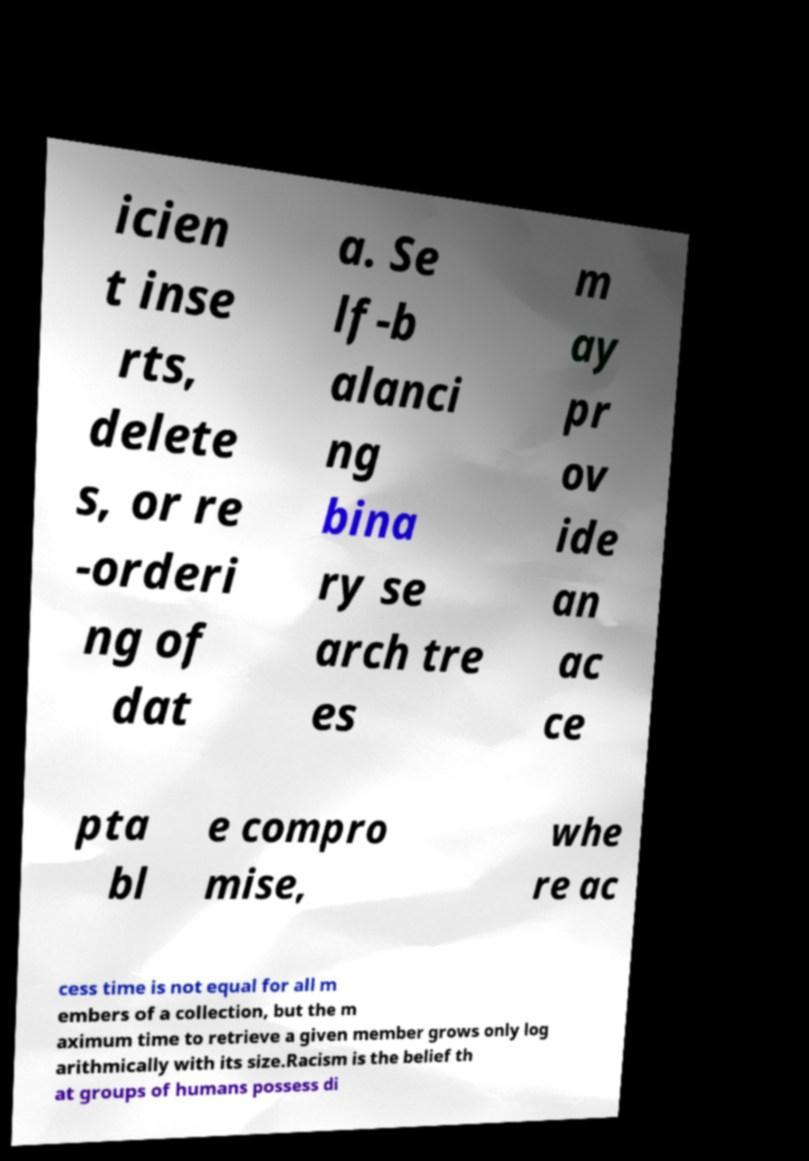Can you accurately transcribe the text from the provided image for me? icien t inse rts, delete s, or re -orderi ng of dat a. Se lf-b alanci ng bina ry se arch tre es m ay pr ov ide an ac ce pta bl e compro mise, whe re ac cess time is not equal for all m embers of a collection, but the m aximum time to retrieve a given member grows only log arithmically with its size.Racism is the belief th at groups of humans possess di 